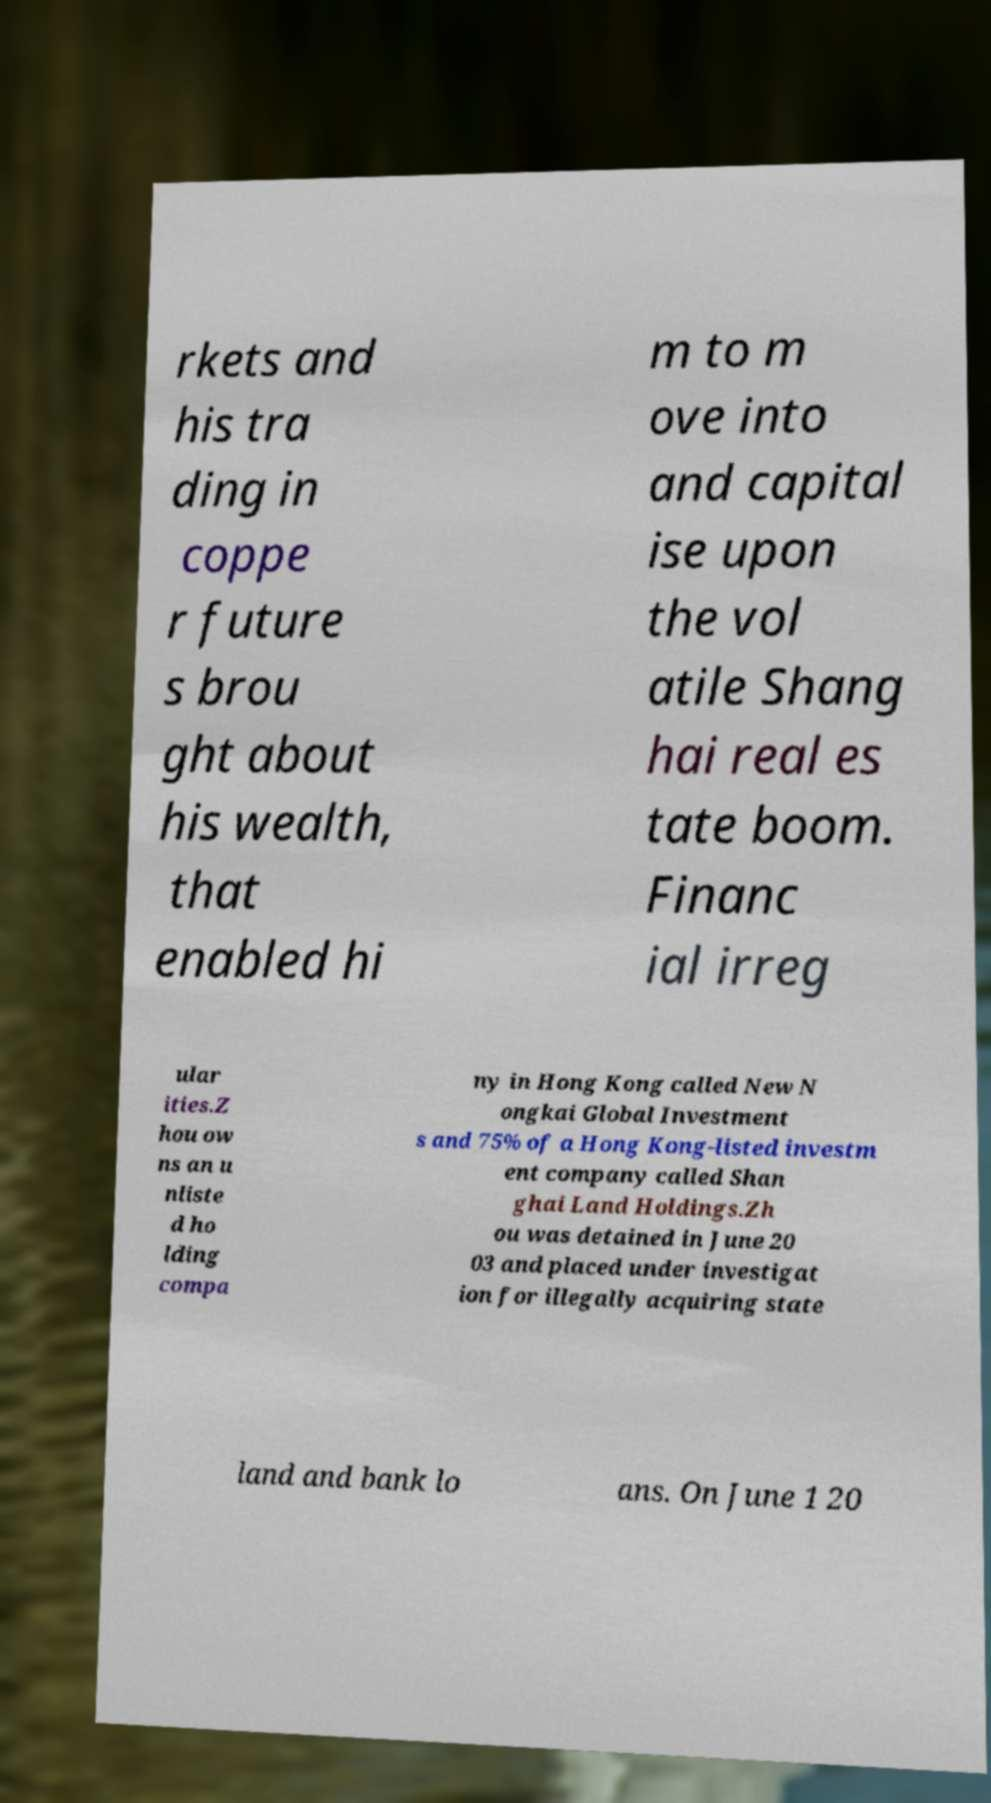Please identify and transcribe the text found in this image. rkets and his tra ding in coppe r future s brou ght about his wealth, that enabled hi m to m ove into and capital ise upon the vol atile Shang hai real es tate boom. Financ ial irreg ular ities.Z hou ow ns an u nliste d ho lding compa ny in Hong Kong called New N ongkai Global Investment s and 75% of a Hong Kong-listed investm ent company called Shan ghai Land Holdings.Zh ou was detained in June 20 03 and placed under investigat ion for illegally acquiring state land and bank lo ans. On June 1 20 